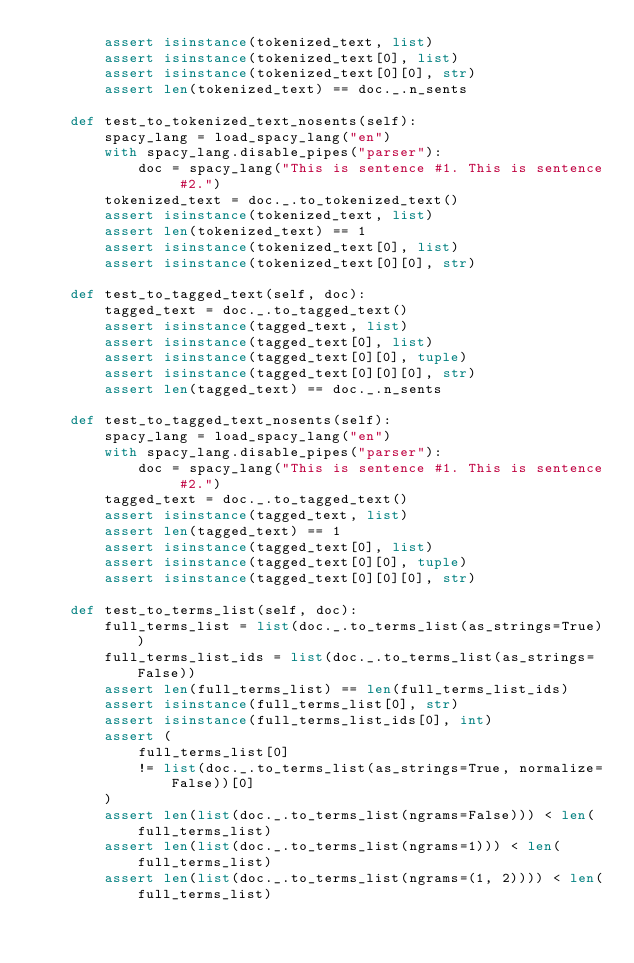Convert code to text. <code><loc_0><loc_0><loc_500><loc_500><_Python_>        assert isinstance(tokenized_text, list)
        assert isinstance(tokenized_text[0], list)
        assert isinstance(tokenized_text[0][0], str)
        assert len(tokenized_text) == doc._.n_sents

    def test_to_tokenized_text_nosents(self):
        spacy_lang = load_spacy_lang("en")
        with spacy_lang.disable_pipes("parser"):
            doc = spacy_lang("This is sentence #1. This is sentence #2.")
        tokenized_text = doc._.to_tokenized_text()
        assert isinstance(tokenized_text, list)
        assert len(tokenized_text) == 1
        assert isinstance(tokenized_text[0], list)
        assert isinstance(tokenized_text[0][0], str)

    def test_to_tagged_text(self, doc):
        tagged_text = doc._.to_tagged_text()
        assert isinstance(tagged_text, list)
        assert isinstance(tagged_text[0], list)
        assert isinstance(tagged_text[0][0], tuple)
        assert isinstance(tagged_text[0][0][0], str)
        assert len(tagged_text) == doc._.n_sents

    def test_to_tagged_text_nosents(self):
        spacy_lang = load_spacy_lang("en")
        with spacy_lang.disable_pipes("parser"):
            doc = spacy_lang("This is sentence #1. This is sentence #2.")
        tagged_text = doc._.to_tagged_text()
        assert isinstance(tagged_text, list)
        assert len(tagged_text) == 1
        assert isinstance(tagged_text[0], list)
        assert isinstance(tagged_text[0][0], tuple)
        assert isinstance(tagged_text[0][0][0], str)

    def test_to_terms_list(self, doc):
        full_terms_list = list(doc._.to_terms_list(as_strings=True))
        full_terms_list_ids = list(doc._.to_terms_list(as_strings=False))
        assert len(full_terms_list) == len(full_terms_list_ids)
        assert isinstance(full_terms_list[0], str)
        assert isinstance(full_terms_list_ids[0], int)
        assert (
            full_terms_list[0]
            != list(doc._.to_terms_list(as_strings=True, normalize=False))[0]
        )
        assert len(list(doc._.to_terms_list(ngrams=False))) < len(full_terms_list)
        assert len(list(doc._.to_terms_list(ngrams=1))) < len(full_terms_list)
        assert len(list(doc._.to_terms_list(ngrams=(1, 2)))) < len(full_terms_list)</code> 